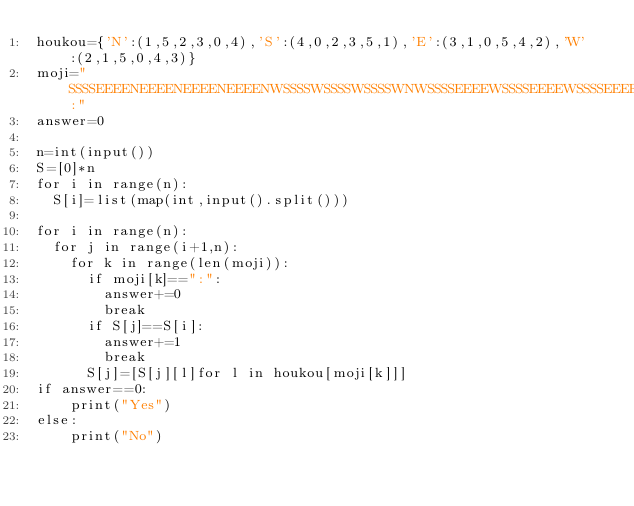<code> <loc_0><loc_0><loc_500><loc_500><_Python_>houkou={'N':(1,5,2,3,0,4),'S':(4,0,2,3,5,1),'E':(3,1,0,5,4,2),'W':(2,1,5,0,4,3)}
moji="SSSSEEEENEEEENEEEENEEEENWSSSSWSSSSWSSSSWNWSSSSEEEEWSSSSEEEEWSSSSEEEEWNWSSSSEEEEWSSSSEEEEWSSSSEEEEWNWSSSSEEEEWSSSSEEEEWSSSSEEEEWN:"
answer=0

n=int(input())
S=[0]*n
for i in range(n):
  S[i]=list(map(int,input().split()))
  
for i in range(n):
  for j in range(i+1,n):
    for k in range(len(moji)):
      if moji[k]==":":
        answer+=0
        break
      if S[j]==S[i]:
        answer+=1
        break
      S[j]=[S[j][l]for l in houkou[moji[k]]]
if answer==0:
    print("Yes")
else:
    print("No")
</code> 